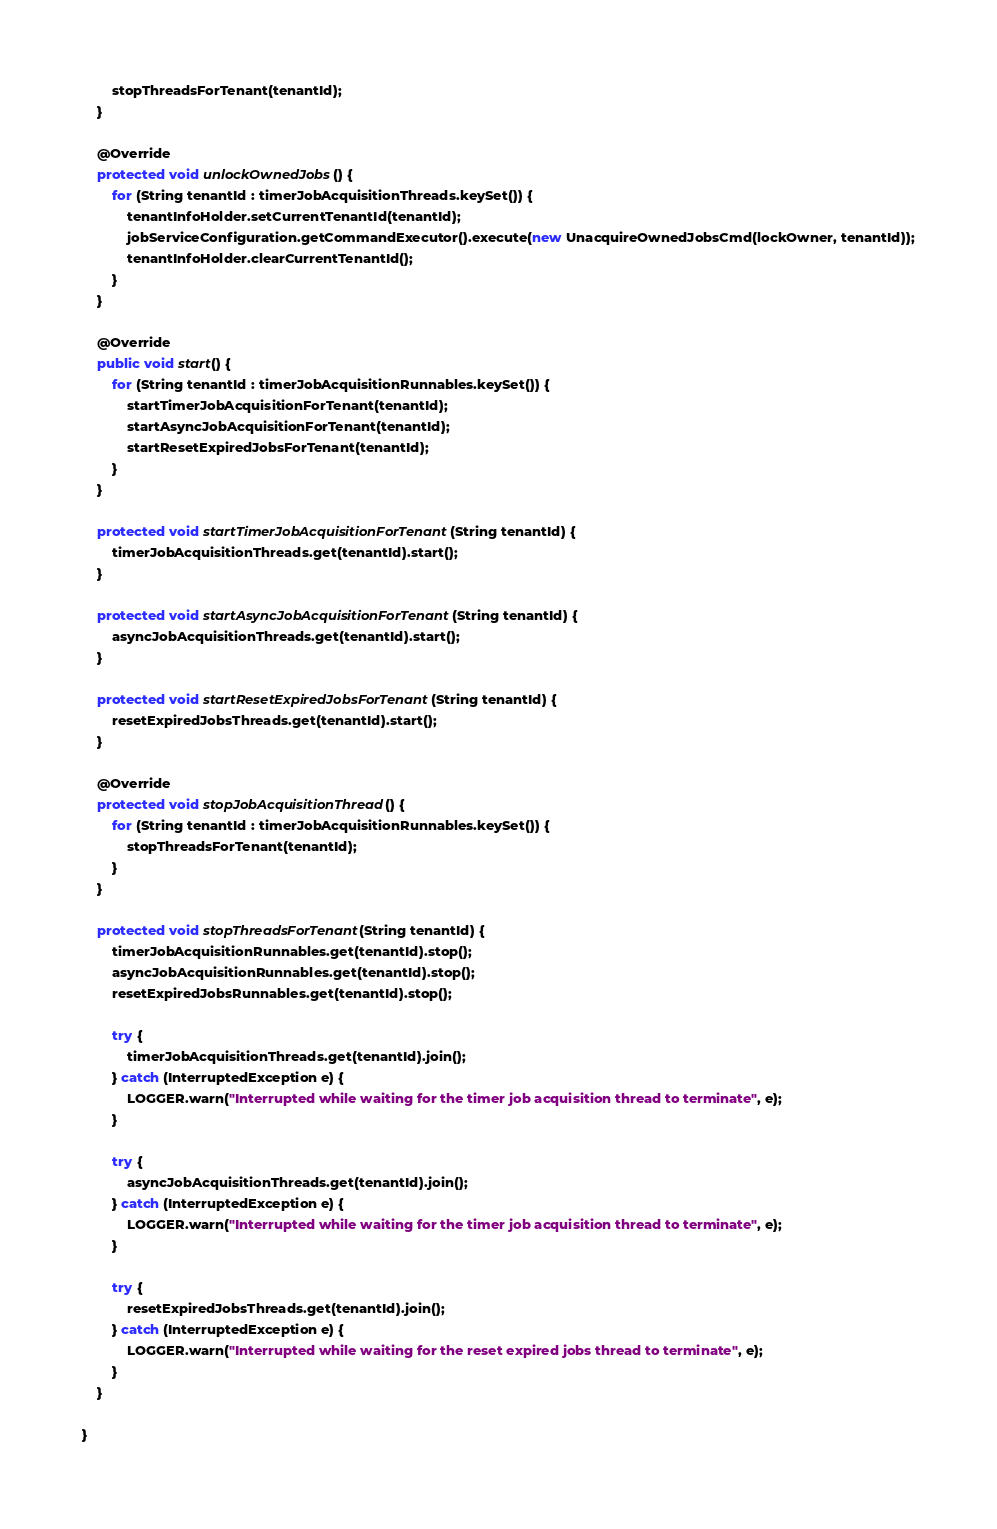<code> <loc_0><loc_0><loc_500><loc_500><_Java_>        stopThreadsForTenant(tenantId);
    }

    @Override
    protected void unlockOwnedJobs() {
        for (String tenantId : timerJobAcquisitionThreads.keySet()) {
            tenantInfoHolder.setCurrentTenantId(tenantId);
            jobServiceConfiguration.getCommandExecutor().execute(new UnacquireOwnedJobsCmd(lockOwner, tenantId));
            tenantInfoHolder.clearCurrentTenantId();
        }
    }

    @Override
    public void start() {
        for (String tenantId : timerJobAcquisitionRunnables.keySet()) {
            startTimerJobAcquisitionForTenant(tenantId);
            startAsyncJobAcquisitionForTenant(tenantId);
            startResetExpiredJobsForTenant(tenantId);
        }
    }

    protected void startTimerJobAcquisitionForTenant(String tenantId) {
        timerJobAcquisitionThreads.get(tenantId).start();
    }

    protected void startAsyncJobAcquisitionForTenant(String tenantId) {
        asyncJobAcquisitionThreads.get(tenantId).start();
    }

    protected void startResetExpiredJobsForTenant(String tenantId) {
        resetExpiredJobsThreads.get(tenantId).start();
    }

    @Override
    protected void stopJobAcquisitionThread() {
        for (String tenantId : timerJobAcquisitionRunnables.keySet()) {
            stopThreadsForTenant(tenantId);
        }
    }

    protected void stopThreadsForTenant(String tenantId) {
        timerJobAcquisitionRunnables.get(tenantId).stop();
        asyncJobAcquisitionRunnables.get(tenantId).stop();
        resetExpiredJobsRunnables.get(tenantId).stop();

        try {
            timerJobAcquisitionThreads.get(tenantId).join();
        } catch (InterruptedException e) {
            LOGGER.warn("Interrupted while waiting for the timer job acquisition thread to terminate", e);
        }

        try {
            asyncJobAcquisitionThreads.get(tenantId).join();
        } catch (InterruptedException e) {
            LOGGER.warn("Interrupted while waiting for the timer job acquisition thread to terminate", e);
        }

        try {
            resetExpiredJobsThreads.get(tenantId).join();
        } catch (InterruptedException e) {
            LOGGER.warn("Interrupted while waiting for the reset expired jobs thread to terminate", e);
        }
    }

}
</code> 